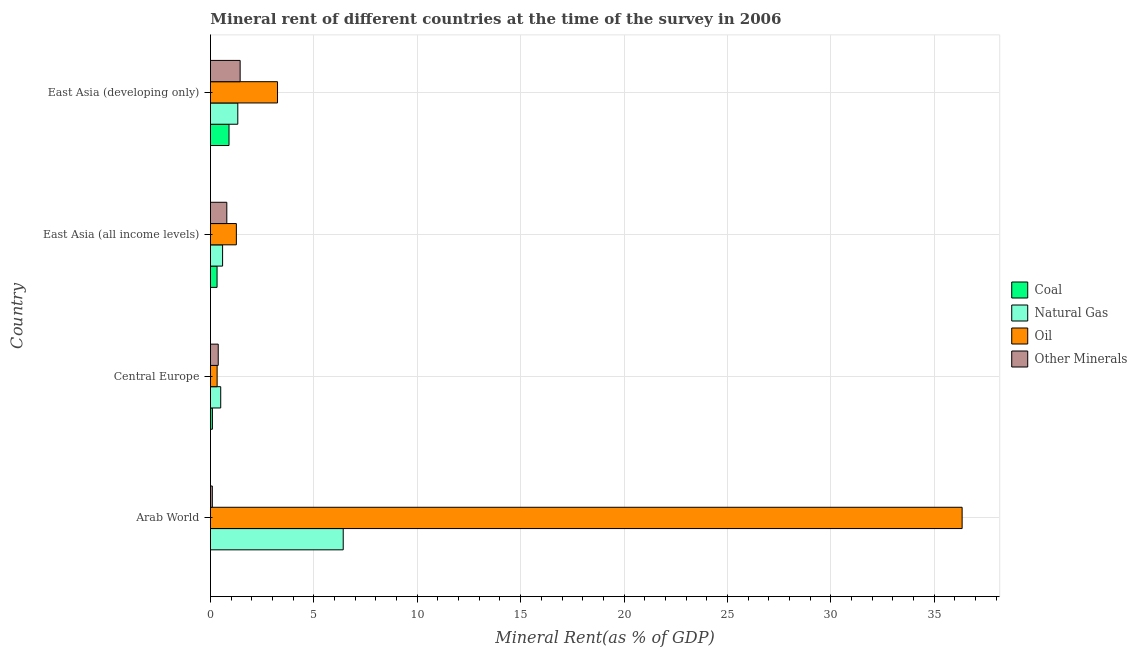How many groups of bars are there?
Keep it short and to the point. 4. Are the number of bars per tick equal to the number of legend labels?
Keep it short and to the point. Yes. How many bars are there on the 2nd tick from the top?
Offer a terse response. 4. What is the label of the 4th group of bars from the top?
Offer a terse response. Arab World. What is the coal rent in East Asia (all income levels)?
Give a very brief answer. 0.32. Across all countries, what is the maximum natural gas rent?
Your response must be concise. 6.42. Across all countries, what is the minimum  rent of other minerals?
Provide a succinct answer. 0.09. In which country was the  rent of other minerals maximum?
Keep it short and to the point. East Asia (developing only). In which country was the  rent of other minerals minimum?
Make the answer very short. Arab World. What is the total coal rent in the graph?
Your answer should be very brief. 1.31. What is the difference between the coal rent in Arab World and that in East Asia (all income levels)?
Your answer should be very brief. -0.32. What is the difference between the  rent of other minerals in East Asia (developing only) and the coal rent in Arab World?
Your response must be concise. 1.43. What is the average  rent of other minerals per country?
Make the answer very short. 0.67. What is the difference between the coal rent and oil rent in Central Europe?
Offer a terse response. -0.23. In how many countries, is the  rent of other minerals greater than 22 %?
Provide a short and direct response. 0. What is the ratio of the coal rent in East Asia (all income levels) to that in East Asia (developing only)?
Your answer should be compact. 0.35. Is the oil rent in Arab World less than that in East Asia (all income levels)?
Your response must be concise. No. Is the difference between the natural gas rent in East Asia (all income levels) and East Asia (developing only) greater than the difference between the oil rent in East Asia (all income levels) and East Asia (developing only)?
Give a very brief answer. Yes. What is the difference between the highest and the second highest  rent of other minerals?
Ensure brevity in your answer.  0.64. What is the difference between the highest and the lowest coal rent?
Give a very brief answer. 0.9. In how many countries, is the oil rent greater than the average oil rent taken over all countries?
Your answer should be compact. 1. Is the sum of the coal rent in Central Europe and East Asia (all income levels) greater than the maximum  rent of other minerals across all countries?
Make the answer very short. No. What does the 1st bar from the top in East Asia (developing only) represents?
Offer a terse response. Other Minerals. What does the 1st bar from the bottom in East Asia (all income levels) represents?
Keep it short and to the point. Coal. Are all the bars in the graph horizontal?
Offer a terse response. Yes. What is the difference between two consecutive major ticks on the X-axis?
Provide a short and direct response. 5. Are the values on the major ticks of X-axis written in scientific E-notation?
Give a very brief answer. No. Does the graph contain grids?
Keep it short and to the point. Yes. What is the title of the graph?
Provide a succinct answer. Mineral rent of different countries at the time of the survey in 2006. What is the label or title of the X-axis?
Your answer should be compact. Mineral Rent(as % of GDP). What is the label or title of the Y-axis?
Provide a succinct answer. Country. What is the Mineral Rent(as % of GDP) in Coal in Arab World?
Provide a succinct answer. 3.10331580007067e-6. What is the Mineral Rent(as % of GDP) of Natural Gas in Arab World?
Offer a very short reply. 6.42. What is the Mineral Rent(as % of GDP) in Oil in Arab World?
Provide a succinct answer. 36.35. What is the Mineral Rent(as % of GDP) of Other Minerals in Arab World?
Give a very brief answer. 0.09. What is the Mineral Rent(as % of GDP) in Coal in Central Europe?
Provide a short and direct response. 0.09. What is the Mineral Rent(as % of GDP) of Natural Gas in Central Europe?
Provide a succinct answer. 0.5. What is the Mineral Rent(as % of GDP) of Oil in Central Europe?
Your response must be concise. 0.32. What is the Mineral Rent(as % of GDP) in Other Minerals in Central Europe?
Make the answer very short. 0.38. What is the Mineral Rent(as % of GDP) of Coal in East Asia (all income levels)?
Provide a short and direct response. 0.32. What is the Mineral Rent(as % of GDP) of Natural Gas in East Asia (all income levels)?
Your answer should be very brief. 0.59. What is the Mineral Rent(as % of GDP) in Oil in East Asia (all income levels)?
Offer a very short reply. 1.25. What is the Mineral Rent(as % of GDP) in Other Minerals in East Asia (all income levels)?
Your answer should be compact. 0.79. What is the Mineral Rent(as % of GDP) in Coal in East Asia (developing only)?
Offer a very short reply. 0.9. What is the Mineral Rent(as % of GDP) of Natural Gas in East Asia (developing only)?
Offer a terse response. 1.32. What is the Mineral Rent(as % of GDP) in Oil in East Asia (developing only)?
Keep it short and to the point. 3.24. What is the Mineral Rent(as % of GDP) of Other Minerals in East Asia (developing only)?
Your response must be concise. 1.43. Across all countries, what is the maximum Mineral Rent(as % of GDP) in Coal?
Give a very brief answer. 0.9. Across all countries, what is the maximum Mineral Rent(as % of GDP) in Natural Gas?
Offer a terse response. 6.42. Across all countries, what is the maximum Mineral Rent(as % of GDP) in Oil?
Your response must be concise. 36.35. Across all countries, what is the maximum Mineral Rent(as % of GDP) in Other Minerals?
Keep it short and to the point. 1.43. Across all countries, what is the minimum Mineral Rent(as % of GDP) of Coal?
Ensure brevity in your answer.  3.10331580007067e-6. Across all countries, what is the minimum Mineral Rent(as % of GDP) in Natural Gas?
Ensure brevity in your answer.  0.5. Across all countries, what is the minimum Mineral Rent(as % of GDP) in Oil?
Give a very brief answer. 0.32. Across all countries, what is the minimum Mineral Rent(as % of GDP) of Other Minerals?
Your answer should be compact. 0.09. What is the total Mineral Rent(as % of GDP) in Coal in the graph?
Your answer should be very brief. 1.31. What is the total Mineral Rent(as % of GDP) of Natural Gas in the graph?
Ensure brevity in your answer.  8.82. What is the total Mineral Rent(as % of GDP) of Oil in the graph?
Provide a short and direct response. 41.17. What is the total Mineral Rent(as % of GDP) of Other Minerals in the graph?
Give a very brief answer. 2.69. What is the difference between the Mineral Rent(as % of GDP) of Coal in Arab World and that in Central Europe?
Your response must be concise. -0.09. What is the difference between the Mineral Rent(as % of GDP) of Natural Gas in Arab World and that in Central Europe?
Make the answer very short. 5.92. What is the difference between the Mineral Rent(as % of GDP) in Oil in Arab World and that in Central Europe?
Your answer should be compact. 36.03. What is the difference between the Mineral Rent(as % of GDP) in Other Minerals in Arab World and that in Central Europe?
Offer a terse response. -0.29. What is the difference between the Mineral Rent(as % of GDP) in Coal in Arab World and that in East Asia (all income levels)?
Provide a short and direct response. -0.32. What is the difference between the Mineral Rent(as % of GDP) in Natural Gas in Arab World and that in East Asia (all income levels)?
Your answer should be very brief. 5.83. What is the difference between the Mineral Rent(as % of GDP) in Oil in Arab World and that in East Asia (all income levels)?
Your response must be concise. 35.1. What is the difference between the Mineral Rent(as % of GDP) in Other Minerals in Arab World and that in East Asia (all income levels)?
Keep it short and to the point. -0.7. What is the difference between the Mineral Rent(as % of GDP) of Coal in Arab World and that in East Asia (developing only)?
Provide a succinct answer. -0.9. What is the difference between the Mineral Rent(as % of GDP) of Natural Gas in Arab World and that in East Asia (developing only)?
Offer a terse response. 5.1. What is the difference between the Mineral Rent(as % of GDP) in Oil in Arab World and that in East Asia (developing only)?
Ensure brevity in your answer.  33.11. What is the difference between the Mineral Rent(as % of GDP) of Other Minerals in Arab World and that in East Asia (developing only)?
Keep it short and to the point. -1.34. What is the difference between the Mineral Rent(as % of GDP) in Coal in Central Europe and that in East Asia (all income levels)?
Offer a very short reply. -0.23. What is the difference between the Mineral Rent(as % of GDP) in Natural Gas in Central Europe and that in East Asia (all income levels)?
Your answer should be compact. -0.09. What is the difference between the Mineral Rent(as % of GDP) of Oil in Central Europe and that in East Asia (all income levels)?
Keep it short and to the point. -0.93. What is the difference between the Mineral Rent(as % of GDP) of Other Minerals in Central Europe and that in East Asia (all income levels)?
Make the answer very short. -0.41. What is the difference between the Mineral Rent(as % of GDP) of Coal in Central Europe and that in East Asia (developing only)?
Offer a terse response. -0.8. What is the difference between the Mineral Rent(as % of GDP) in Natural Gas in Central Europe and that in East Asia (developing only)?
Provide a short and direct response. -0.83. What is the difference between the Mineral Rent(as % of GDP) in Oil in Central Europe and that in East Asia (developing only)?
Give a very brief answer. -2.92. What is the difference between the Mineral Rent(as % of GDP) of Other Minerals in Central Europe and that in East Asia (developing only)?
Your answer should be compact. -1.06. What is the difference between the Mineral Rent(as % of GDP) of Coal in East Asia (all income levels) and that in East Asia (developing only)?
Ensure brevity in your answer.  -0.58. What is the difference between the Mineral Rent(as % of GDP) in Natural Gas in East Asia (all income levels) and that in East Asia (developing only)?
Give a very brief answer. -0.74. What is the difference between the Mineral Rent(as % of GDP) of Oil in East Asia (all income levels) and that in East Asia (developing only)?
Make the answer very short. -1.99. What is the difference between the Mineral Rent(as % of GDP) of Other Minerals in East Asia (all income levels) and that in East Asia (developing only)?
Your answer should be very brief. -0.64. What is the difference between the Mineral Rent(as % of GDP) in Coal in Arab World and the Mineral Rent(as % of GDP) in Natural Gas in Central Europe?
Ensure brevity in your answer.  -0.5. What is the difference between the Mineral Rent(as % of GDP) in Coal in Arab World and the Mineral Rent(as % of GDP) in Oil in Central Europe?
Provide a short and direct response. -0.32. What is the difference between the Mineral Rent(as % of GDP) of Coal in Arab World and the Mineral Rent(as % of GDP) of Other Minerals in Central Europe?
Offer a very short reply. -0.38. What is the difference between the Mineral Rent(as % of GDP) in Natural Gas in Arab World and the Mineral Rent(as % of GDP) in Oil in Central Europe?
Provide a short and direct response. 6.1. What is the difference between the Mineral Rent(as % of GDP) of Natural Gas in Arab World and the Mineral Rent(as % of GDP) of Other Minerals in Central Europe?
Provide a short and direct response. 6.04. What is the difference between the Mineral Rent(as % of GDP) of Oil in Arab World and the Mineral Rent(as % of GDP) of Other Minerals in Central Europe?
Make the answer very short. 35.97. What is the difference between the Mineral Rent(as % of GDP) of Coal in Arab World and the Mineral Rent(as % of GDP) of Natural Gas in East Asia (all income levels)?
Your answer should be very brief. -0.59. What is the difference between the Mineral Rent(as % of GDP) of Coal in Arab World and the Mineral Rent(as % of GDP) of Oil in East Asia (all income levels)?
Make the answer very short. -1.25. What is the difference between the Mineral Rent(as % of GDP) in Coal in Arab World and the Mineral Rent(as % of GDP) in Other Minerals in East Asia (all income levels)?
Ensure brevity in your answer.  -0.79. What is the difference between the Mineral Rent(as % of GDP) of Natural Gas in Arab World and the Mineral Rent(as % of GDP) of Oil in East Asia (all income levels)?
Keep it short and to the point. 5.17. What is the difference between the Mineral Rent(as % of GDP) in Natural Gas in Arab World and the Mineral Rent(as % of GDP) in Other Minerals in East Asia (all income levels)?
Offer a terse response. 5.63. What is the difference between the Mineral Rent(as % of GDP) in Oil in Arab World and the Mineral Rent(as % of GDP) in Other Minerals in East Asia (all income levels)?
Provide a short and direct response. 35.56. What is the difference between the Mineral Rent(as % of GDP) in Coal in Arab World and the Mineral Rent(as % of GDP) in Natural Gas in East Asia (developing only)?
Keep it short and to the point. -1.32. What is the difference between the Mineral Rent(as % of GDP) of Coal in Arab World and the Mineral Rent(as % of GDP) of Oil in East Asia (developing only)?
Ensure brevity in your answer.  -3.24. What is the difference between the Mineral Rent(as % of GDP) of Coal in Arab World and the Mineral Rent(as % of GDP) of Other Minerals in East Asia (developing only)?
Give a very brief answer. -1.43. What is the difference between the Mineral Rent(as % of GDP) in Natural Gas in Arab World and the Mineral Rent(as % of GDP) in Oil in East Asia (developing only)?
Give a very brief answer. 3.18. What is the difference between the Mineral Rent(as % of GDP) in Natural Gas in Arab World and the Mineral Rent(as % of GDP) in Other Minerals in East Asia (developing only)?
Provide a short and direct response. 4.99. What is the difference between the Mineral Rent(as % of GDP) of Oil in Arab World and the Mineral Rent(as % of GDP) of Other Minerals in East Asia (developing only)?
Provide a short and direct response. 34.92. What is the difference between the Mineral Rent(as % of GDP) of Coal in Central Europe and the Mineral Rent(as % of GDP) of Natural Gas in East Asia (all income levels)?
Offer a very short reply. -0.49. What is the difference between the Mineral Rent(as % of GDP) of Coal in Central Europe and the Mineral Rent(as % of GDP) of Oil in East Asia (all income levels)?
Provide a succinct answer. -1.16. What is the difference between the Mineral Rent(as % of GDP) in Coal in Central Europe and the Mineral Rent(as % of GDP) in Other Minerals in East Asia (all income levels)?
Give a very brief answer. -0.7. What is the difference between the Mineral Rent(as % of GDP) of Natural Gas in Central Europe and the Mineral Rent(as % of GDP) of Oil in East Asia (all income levels)?
Keep it short and to the point. -0.76. What is the difference between the Mineral Rent(as % of GDP) in Natural Gas in Central Europe and the Mineral Rent(as % of GDP) in Other Minerals in East Asia (all income levels)?
Keep it short and to the point. -0.29. What is the difference between the Mineral Rent(as % of GDP) of Oil in Central Europe and the Mineral Rent(as % of GDP) of Other Minerals in East Asia (all income levels)?
Make the answer very short. -0.47. What is the difference between the Mineral Rent(as % of GDP) of Coal in Central Europe and the Mineral Rent(as % of GDP) of Natural Gas in East Asia (developing only)?
Offer a very short reply. -1.23. What is the difference between the Mineral Rent(as % of GDP) in Coal in Central Europe and the Mineral Rent(as % of GDP) in Oil in East Asia (developing only)?
Make the answer very short. -3.15. What is the difference between the Mineral Rent(as % of GDP) in Coal in Central Europe and the Mineral Rent(as % of GDP) in Other Minerals in East Asia (developing only)?
Your answer should be compact. -1.34. What is the difference between the Mineral Rent(as % of GDP) of Natural Gas in Central Europe and the Mineral Rent(as % of GDP) of Oil in East Asia (developing only)?
Your response must be concise. -2.75. What is the difference between the Mineral Rent(as % of GDP) in Natural Gas in Central Europe and the Mineral Rent(as % of GDP) in Other Minerals in East Asia (developing only)?
Offer a terse response. -0.94. What is the difference between the Mineral Rent(as % of GDP) of Oil in Central Europe and the Mineral Rent(as % of GDP) of Other Minerals in East Asia (developing only)?
Provide a succinct answer. -1.11. What is the difference between the Mineral Rent(as % of GDP) of Coal in East Asia (all income levels) and the Mineral Rent(as % of GDP) of Natural Gas in East Asia (developing only)?
Your response must be concise. -1. What is the difference between the Mineral Rent(as % of GDP) of Coal in East Asia (all income levels) and the Mineral Rent(as % of GDP) of Oil in East Asia (developing only)?
Your answer should be very brief. -2.92. What is the difference between the Mineral Rent(as % of GDP) of Coal in East Asia (all income levels) and the Mineral Rent(as % of GDP) of Other Minerals in East Asia (developing only)?
Your answer should be very brief. -1.12. What is the difference between the Mineral Rent(as % of GDP) of Natural Gas in East Asia (all income levels) and the Mineral Rent(as % of GDP) of Oil in East Asia (developing only)?
Offer a very short reply. -2.66. What is the difference between the Mineral Rent(as % of GDP) in Natural Gas in East Asia (all income levels) and the Mineral Rent(as % of GDP) in Other Minerals in East Asia (developing only)?
Offer a terse response. -0.85. What is the difference between the Mineral Rent(as % of GDP) in Oil in East Asia (all income levels) and the Mineral Rent(as % of GDP) in Other Minerals in East Asia (developing only)?
Offer a terse response. -0.18. What is the average Mineral Rent(as % of GDP) of Coal per country?
Ensure brevity in your answer.  0.33. What is the average Mineral Rent(as % of GDP) in Natural Gas per country?
Keep it short and to the point. 2.21. What is the average Mineral Rent(as % of GDP) of Oil per country?
Your answer should be very brief. 10.29. What is the average Mineral Rent(as % of GDP) in Other Minerals per country?
Keep it short and to the point. 0.67. What is the difference between the Mineral Rent(as % of GDP) of Coal and Mineral Rent(as % of GDP) of Natural Gas in Arab World?
Provide a succinct answer. -6.42. What is the difference between the Mineral Rent(as % of GDP) in Coal and Mineral Rent(as % of GDP) in Oil in Arab World?
Ensure brevity in your answer.  -36.35. What is the difference between the Mineral Rent(as % of GDP) in Coal and Mineral Rent(as % of GDP) in Other Minerals in Arab World?
Make the answer very short. -0.09. What is the difference between the Mineral Rent(as % of GDP) of Natural Gas and Mineral Rent(as % of GDP) of Oil in Arab World?
Keep it short and to the point. -29.93. What is the difference between the Mineral Rent(as % of GDP) in Natural Gas and Mineral Rent(as % of GDP) in Other Minerals in Arab World?
Give a very brief answer. 6.33. What is the difference between the Mineral Rent(as % of GDP) of Oil and Mineral Rent(as % of GDP) of Other Minerals in Arab World?
Give a very brief answer. 36.26. What is the difference between the Mineral Rent(as % of GDP) in Coal and Mineral Rent(as % of GDP) in Natural Gas in Central Europe?
Offer a very short reply. -0.4. What is the difference between the Mineral Rent(as % of GDP) of Coal and Mineral Rent(as % of GDP) of Oil in Central Europe?
Your answer should be compact. -0.23. What is the difference between the Mineral Rent(as % of GDP) of Coal and Mineral Rent(as % of GDP) of Other Minerals in Central Europe?
Your answer should be compact. -0.28. What is the difference between the Mineral Rent(as % of GDP) in Natural Gas and Mineral Rent(as % of GDP) in Oil in Central Europe?
Give a very brief answer. 0.17. What is the difference between the Mineral Rent(as % of GDP) of Natural Gas and Mineral Rent(as % of GDP) of Other Minerals in Central Europe?
Keep it short and to the point. 0.12. What is the difference between the Mineral Rent(as % of GDP) of Oil and Mineral Rent(as % of GDP) of Other Minerals in Central Europe?
Your response must be concise. -0.05. What is the difference between the Mineral Rent(as % of GDP) in Coal and Mineral Rent(as % of GDP) in Natural Gas in East Asia (all income levels)?
Your answer should be compact. -0.27. What is the difference between the Mineral Rent(as % of GDP) in Coal and Mineral Rent(as % of GDP) in Oil in East Asia (all income levels)?
Your response must be concise. -0.93. What is the difference between the Mineral Rent(as % of GDP) in Coal and Mineral Rent(as % of GDP) in Other Minerals in East Asia (all income levels)?
Offer a terse response. -0.47. What is the difference between the Mineral Rent(as % of GDP) in Natural Gas and Mineral Rent(as % of GDP) in Oil in East Asia (all income levels)?
Make the answer very short. -0.67. What is the difference between the Mineral Rent(as % of GDP) in Natural Gas and Mineral Rent(as % of GDP) in Other Minerals in East Asia (all income levels)?
Offer a very short reply. -0.2. What is the difference between the Mineral Rent(as % of GDP) in Oil and Mineral Rent(as % of GDP) in Other Minerals in East Asia (all income levels)?
Your response must be concise. 0.46. What is the difference between the Mineral Rent(as % of GDP) in Coal and Mineral Rent(as % of GDP) in Natural Gas in East Asia (developing only)?
Keep it short and to the point. -0.42. What is the difference between the Mineral Rent(as % of GDP) in Coal and Mineral Rent(as % of GDP) in Oil in East Asia (developing only)?
Give a very brief answer. -2.35. What is the difference between the Mineral Rent(as % of GDP) in Coal and Mineral Rent(as % of GDP) in Other Minerals in East Asia (developing only)?
Make the answer very short. -0.54. What is the difference between the Mineral Rent(as % of GDP) of Natural Gas and Mineral Rent(as % of GDP) of Oil in East Asia (developing only)?
Provide a succinct answer. -1.92. What is the difference between the Mineral Rent(as % of GDP) of Natural Gas and Mineral Rent(as % of GDP) of Other Minerals in East Asia (developing only)?
Offer a very short reply. -0.11. What is the difference between the Mineral Rent(as % of GDP) in Oil and Mineral Rent(as % of GDP) in Other Minerals in East Asia (developing only)?
Your answer should be very brief. 1.81. What is the ratio of the Mineral Rent(as % of GDP) of Coal in Arab World to that in Central Europe?
Make the answer very short. 0. What is the ratio of the Mineral Rent(as % of GDP) in Natural Gas in Arab World to that in Central Europe?
Provide a succinct answer. 12.95. What is the ratio of the Mineral Rent(as % of GDP) in Oil in Arab World to that in Central Europe?
Make the answer very short. 112.93. What is the ratio of the Mineral Rent(as % of GDP) of Other Minerals in Arab World to that in Central Europe?
Offer a very short reply. 0.24. What is the ratio of the Mineral Rent(as % of GDP) in Coal in Arab World to that in East Asia (all income levels)?
Offer a very short reply. 0. What is the ratio of the Mineral Rent(as % of GDP) in Natural Gas in Arab World to that in East Asia (all income levels)?
Make the answer very short. 10.96. What is the ratio of the Mineral Rent(as % of GDP) in Oil in Arab World to that in East Asia (all income levels)?
Offer a terse response. 29.04. What is the ratio of the Mineral Rent(as % of GDP) of Other Minerals in Arab World to that in East Asia (all income levels)?
Provide a short and direct response. 0.11. What is the ratio of the Mineral Rent(as % of GDP) in Coal in Arab World to that in East Asia (developing only)?
Provide a short and direct response. 0. What is the ratio of the Mineral Rent(as % of GDP) in Natural Gas in Arab World to that in East Asia (developing only)?
Your answer should be very brief. 4.86. What is the ratio of the Mineral Rent(as % of GDP) in Oil in Arab World to that in East Asia (developing only)?
Your answer should be compact. 11.21. What is the ratio of the Mineral Rent(as % of GDP) in Other Minerals in Arab World to that in East Asia (developing only)?
Keep it short and to the point. 0.06. What is the ratio of the Mineral Rent(as % of GDP) in Coal in Central Europe to that in East Asia (all income levels)?
Provide a succinct answer. 0.29. What is the ratio of the Mineral Rent(as % of GDP) in Natural Gas in Central Europe to that in East Asia (all income levels)?
Offer a very short reply. 0.85. What is the ratio of the Mineral Rent(as % of GDP) of Oil in Central Europe to that in East Asia (all income levels)?
Give a very brief answer. 0.26. What is the ratio of the Mineral Rent(as % of GDP) of Other Minerals in Central Europe to that in East Asia (all income levels)?
Ensure brevity in your answer.  0.48. What is the ratio of the Mineral Rent(as % of GDP) of Coal in Central Europe to that in East Asia (developing only)?
Your answer should be compact. 0.1. What is the ratio of the Mineral Rent(as % of GDP) in Natural Gas in Central Europe to that in East Asia (developing only)?
Provide a short and direct response. 0.38. What is the ratio of the Mineral Rent(as % of GDP) in Oil in Central Europe to that in East Asia (developing only)?
Offer a terse response. 0.1. What is the ratio of the Mineral Rent(as % of GDP) of Other Minerals in Central Europe to that in East Asia (developing only)?
Give a very brief answer. 0.26. What is the ratio of the Mineral Rent(as % of GDP) in Coal in East Asia (all income levels) to that in East Asia (developing only)?
Make the answer very short. 0.36. What is the ratio of the Mineral Rent(as % of GDP) in Natural Gas in East Asia (all income levels) to that in East Asia (developing only)?
Your answer should be compact. 0.44. What is the ratio of the Mineral Rent(as % of GDP) in Oil in East Asia (all income levels) to that in East Asia (developing only)?
Ensure brevity in your answer.  0.39. What is the ratio of the Mineral Rent(as % of GDP) of Other Minerals in East Asia (all income levels) to that in East Asia (developing only)?
Keep it short and to the point. 0.55. What is the difference between the highest and the second highest Mineral Rent(as % of GDP) of Coal?
Give a very brief answer. 0.58. What is the difference between the highest and the second highest Mineral Rent(as % of GDP) in Natural Gas?
Provide a short and direct response. 5.1. What is the difference between the highest and the second highest Mineral Rent(as % of GDP) of Oil?
Your response must be concise. 33.11. What is the difference between the highest and the second highest Mineral Rent(as % of GDP) in Other Minerals?
Make the answer very short. 0.64. What is the difference between the highest and the lowest Mineral Rent(as % of GDP) of Coal?
Provide a succinct answer. 0.9. What is the difference between the highest and the lowest Mineral Rent(as % of GDP) of Natural Gas?
Your answer should be compact. 5.92. What is the difference between the highest and the lowest Mineral Rent(as % of GDP) in Oil?
Provide a succinct answer. 36.03. What is the difference between the highest and the lowest Mineral Rent(as % of GDP) of Other Minerals?
Your answer should be very brief. 1.34. 